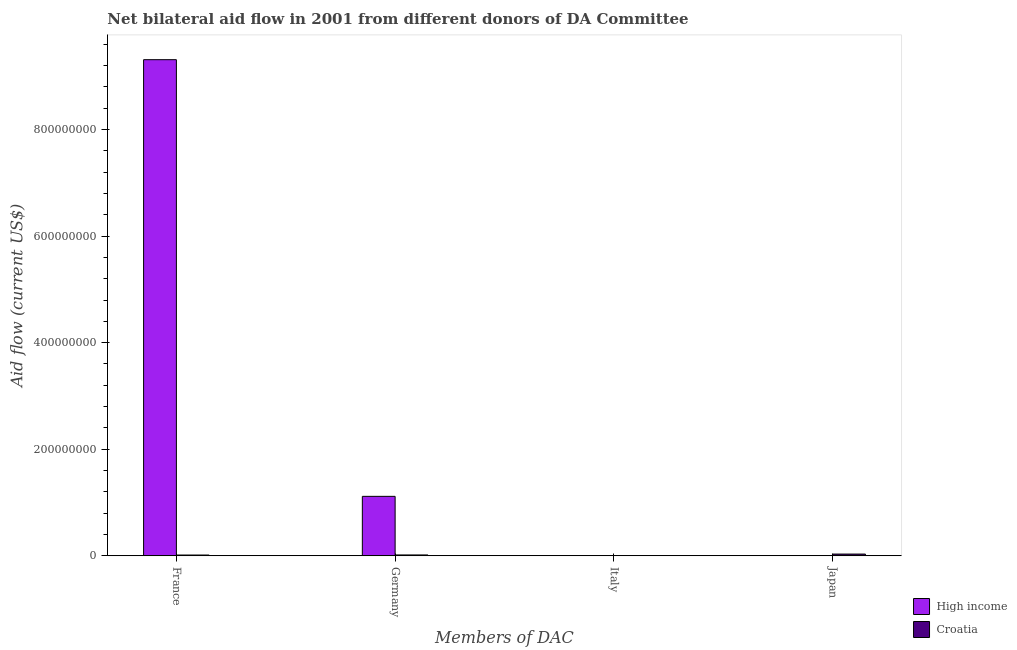Are the number of bars on each tick of the X-axis equal?
Your response must be concise. No. How many bars are there on the 1st tick from the right?
Keep it short and to the point. 1. What is the amount of aid given by japan in Croatia?
Your answer should be compact. 3.24e+06. Across all countries, what is the maximum amount of aid given by france?
Offer a terse response. 9.31e+08. Across all countries, what is the minimum amount of aid given by italy?
Your response must be concise. 0. What is the total amount of aid given by germany in the graph?
Provide a succinct answer. 1.13e+08. What is the difference between the amount of aid given by france in High income and that in Croatia?
Give a very brief answer. 9.30e+08. What is the difference between the amount of aid given by italy in Croatia and the amount of aid given by japan in High income?
Your response must be concise. 0. What is the difference between the amount of aid given by germany and amount of aid given by japan in Croatia?
Provide a short and direct response. -1.66e+06. In how many countries, is the amount of aid given by germany greater than 560000000 US$?
Provide a short and direct response. 0. What is the ratio of the amount of aid given by france in Croatia to that in High income?
Offer a terse response. 0. What is the difference between the highest and the second highest amount of aid given by france?
Offer a very short reply. 9.30e+08. What is the difference between the highest and the lowest amount of aid given by germany?
Make the answer very short. 1.10e+08. Is it the case that in every country, the sum of the amount of aid given by italy and amount of aid given by france is greater than the sum of amount of aid given by japan and amount of aid given by germany?
Your answer should be compact. No. How many bars are there?
Your answer should be compact. 5. What is the difference between two consecutive major ticks on the Y-axis?
Provide a short and direct response. 2.00e+08. Are the values on the major ticks of Y-axis written in scientific E-notation?
Provide a succinct answer. No. Does the graph contain any zero values?
Provide a succinct answer. Yes. How are the legend labels stacked?
Your response must be concise. Vertical. What is the title of the graph?
Ensure brevity in your answer.  Net bilateral aid flow in 2001 from different donors of DA Committee. Does "Bulgaria" appear as one of the legend labels in the graph?
Your response must be concise. No. What is the label or title of the X-axis?
Make the answer very short. Members of DAC. What is the label or title of the Y-axis?
Your answer should be compact. Aid flow (current US$). What is the Aid flow (current US$) in High income in France?
Ensure brevity in your answer.  9.31e+08. What is the Aid flow (current US$) in Croatia in France?
Your response must be concise. 1.43e+06. What is the Aid flow (current US$) of High income in Germany?
Your response must be concise. 1.12e+08. What is the Aid flow (current US$) of Croatia in Germany?
Make the answer very short. 1.58e+06. What is the Aid flow (current US$) of High income in Italy?
Your answer should be very brief. 0. What is the Aid flow (current US$) of Croatia in Italy?
Offer a terse response. 0. What is the Aid flow (current US$) in Croatia in Japan?
Your answer should be compact. 3.24e+06. Across all Members of DAC, what is the maximum Aid flow (current US$) in High income?
Offer a very short reply. 9.31e+08. Across all Members of DAC, what is the maximum Aid flow (current US$) of Croatia?
Provide a succinct answer. 3.24e+06. Across all Members of DAC, what is the minimum Aid flow (current US$) in High income?
Keep it short and to the point. 0. What is the total Aid flow (current US$) of High income in the graph?
Give a very brief answer. 1.04e+09. What is the total Aid flow (current US$) in Croatia in the graph?
Provide a succinct answer. 6.25e+06. What is the difference between the Aid flow (current US$) of High income in France and that in Germany?
Provide a succinct answer. 8.19e+08. What is the difference between the Aid flow (current US$) in Croatia in France and that in Germany?
Give a very brief answer. -1.50e+05. What is the difference between the Aid flow (current US$) in Croatia in France and that in Japan?
Provide a short and direct response. -1.81e+06. What is the difference between the Aid flow (current US$) of Croatia in Germany and that in Japan?
Your answer should be very brief. -1.66e+06. What is the difference between the Aid flow (current US$) of High income in France and the Aid flow (current US$) of Croatia in Germany?
Keep it short and to the point. 9.29e+08. What is the difference between the Aid flow (current US$) of High income in France and the Aid flow (current US$) of Croatia in Japan?
Provide a succinct answer. 9.28e+08. What is the difference between the Aid flow (current US$) of High income in Germany and the Aid flow (current US$) of Croatia in Japan?
Give a very brief answer. 1.08e+08. What is the average Aid flow (current US$) in High income per Members of DAC?
Offer a terse response. 2.61e+08. What is the average Aid flow (current US$) in Croatia per Members of DAC?
Your answer should be very brief. 1.56e+06. What is the difference between the Aid flow (current US$) of High income and Aid flow (current US$) of Croatia in France?
Ensure brevity in your answer.  9.30e+08. What is the difference between the Aid flow (current US$) of High income and Aid flow (current US$) of Croatia in Germany?
Your answer should be compact. 1.10e+08. What is the ratio of the Aid flow (current US$) of High income in France to that in Germany?
Give a very brief answer. 8.35. What is the ratio of the Aid flow (current US$) of Croatia in France to that in Germany?
Give a very brief answer. 0.91. What is the ratio of the Aid flow (current US$) in Croatia in France to that in Japan?
Your answer should be very brief. 0.44. What is the ratio of the Aid flow (current US$) of Croatia in Germany to that in Japan?
Provide a succinct answer. 0.49. What is the difference between the highest and the second highest Aid flow (current US$) in Croatia?
Make the answer very short. 1.66e+06. What is the difference between the highest and the lowest Aid flow (current US$) of High income?
Offer a terse response. 9.31e+08. What is the difference between the highest and the lowest Aid flow (current US$) of Croatia?
Your response must be concise. 3.24e+06. 